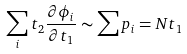<formula> <loc_0><loc_0><loc_500><loc_500>\sum _ { i } t _ { 2 } \frac { \partial \phi _ { i } } { \partial t _ { 1 } } \sim \sum p _ { i } = N t _ { 1 }</formula> 